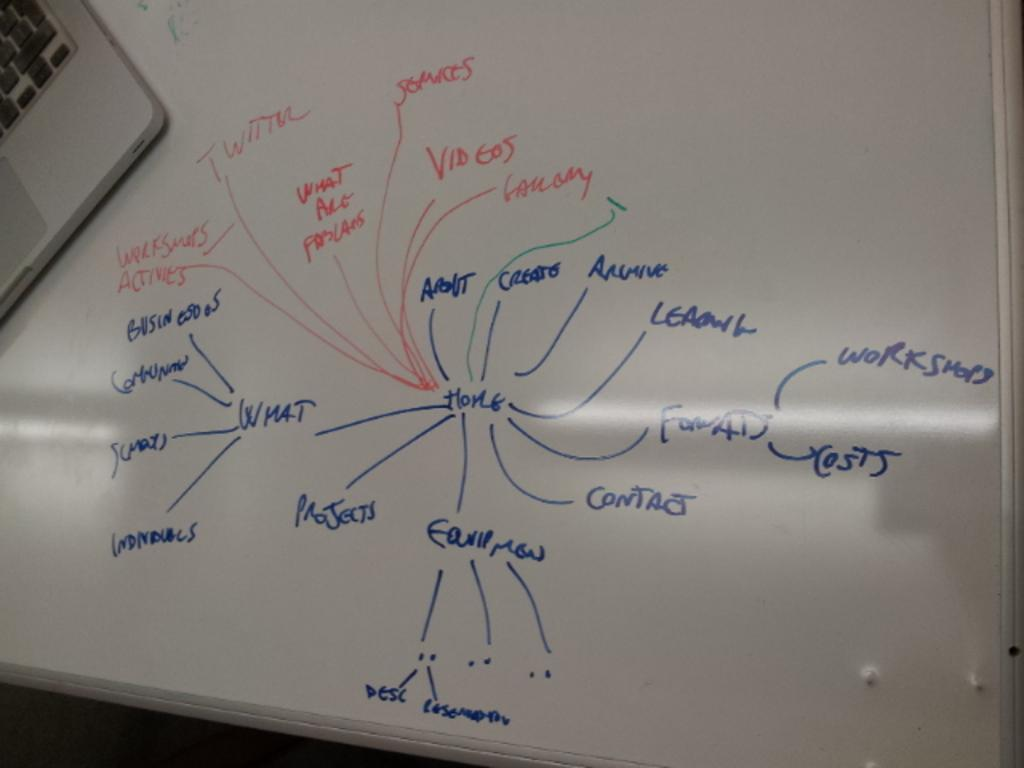<image>
Create a compact narrative representing the image presented. The word home is in the center of several other words, with lines drawn to them to show their relationship. 